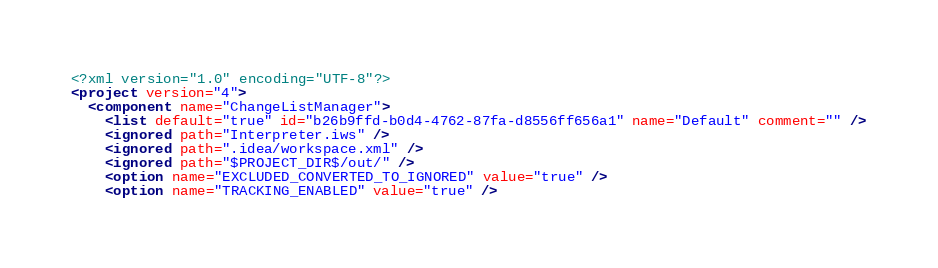Convert code to text. <code><loc_0><loc_0><loc_500><loc_500><_XML_><?xml version="1.0" encoding="UTF-8"?>
<project version="4">
  <component name="ChangeListManager">
    <list default="true" id="b26b9ffd-b0d4-4762-87fa-d8556ff656a1" name="Default" comment="" />
    <ignored path="Interpreter.iws" />
    <ignored path=".idea/workspace.xml" />
    <ignored path="$PROJECT_DIR$/out/" />
    <option name="EXCLUDED_CONVERTED_TO_IGNORED" value="true" />
    <option name="TRACKING_ENABLED" value="true" /></code> 